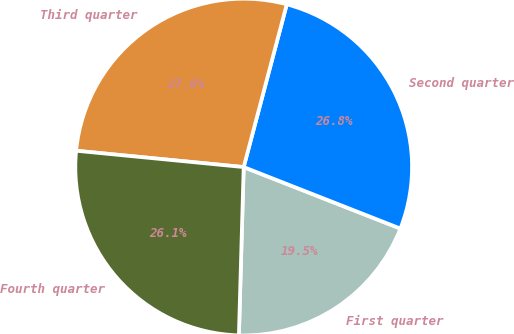Convert chart to OTSL. <chart><loc_0><loc_0><loc_500><loc_500><pie_chart><fcel>First quarter<fcel>Second quarter<fcel>Third quarter<fcel>Fourth quarter<nl><fcel>19.5%<fcel>26.83%<fcel>27.57%<fcel>26.09%<nl></chart> 